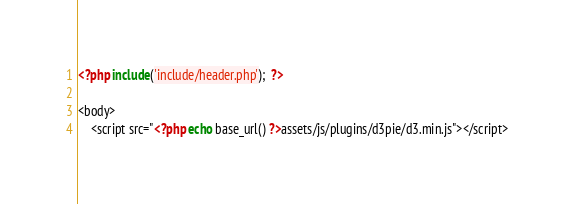<code> <loc_0><loc_0><loc_500><loc_500><_PHP_><?php include('include/header.php');  ?>

<body>
    <script src="<?php echo base_url() ?>assets/js/plugins/d3pie/d3.min.js"></script></code> 